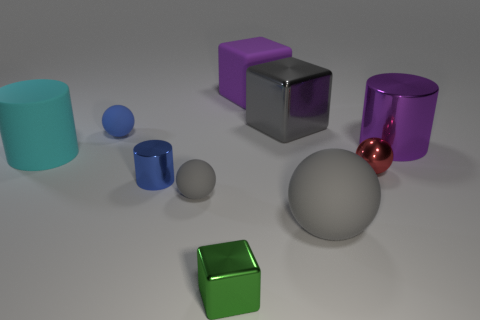Subtract all purple balls. Subtract all purple cylinders. How many balls are left? 4 Subtract all cylinders. How many objects are left? 7 Subtract all red matte cubes. Subtract all tiny green blocks. How many objects are left? 9 Add 9 matte cylinders. How many matte cylinders are left? 10 Add 7 tiny metal spheres. How many tiny metal spheres exist? 8 Subtract 0 cyan cubes. How many objects are left? 10 